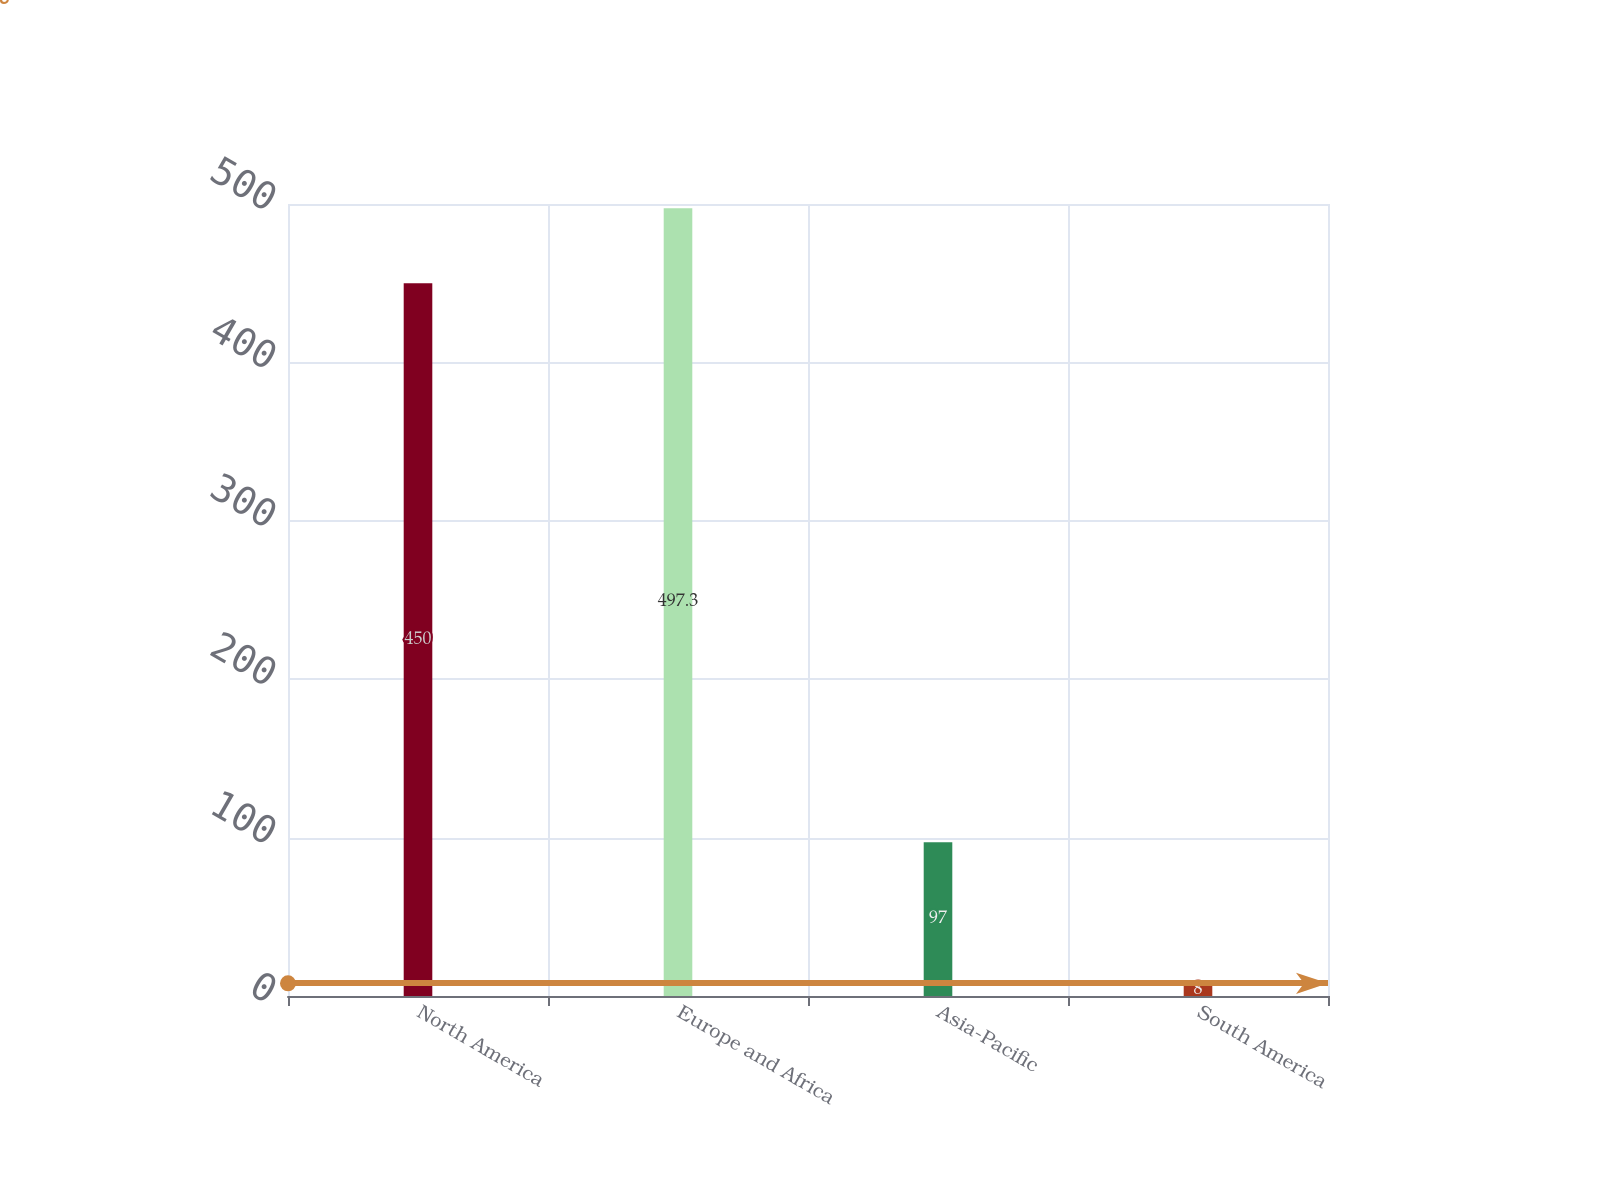Convert chart to OTSL. <chart><loc_0><loc_0><loc_500><loc_500><bar_chart><fcel>North America<fcel>Europe and Africa<fcel>Asia-Pacific<fcel>South America<nl><fcel>450<fcel>497.3<fcel>97<fcel>8<nl></chart> 